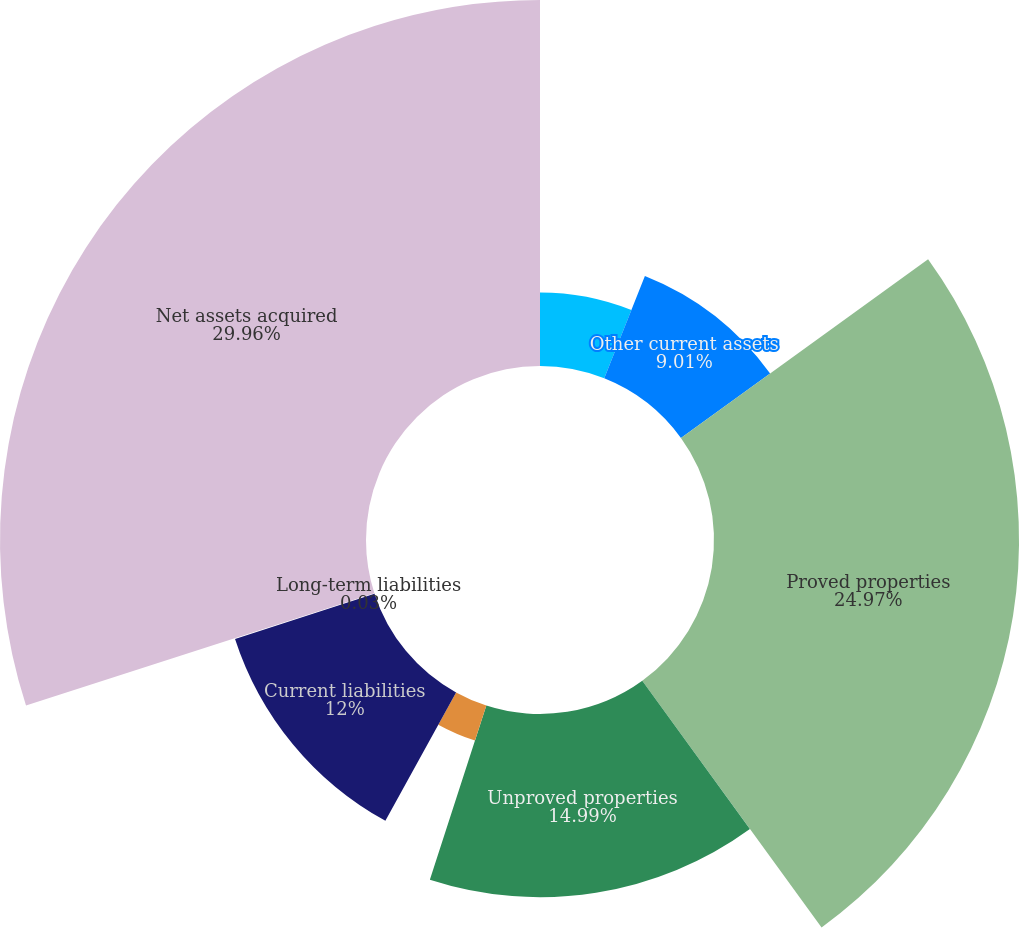<chart> <loc_0><loc_0><loc_500><loc_500><pie_chart><fcel>Cash and cash equivalents<fcel>Other current assets<fcel>Proved properties<fcel>Unproved properties<fcel>Midstream assets<fcel>Current liabilities<fcel>Long-term liabilities<fcel>Net assets acquired<nl><fcel>6.02%<fcel>9.01%<fcel>24.97%<fcel>14.99%<fcel>3.02%<fcel>12.0%<fcel>0.03%<fcel>29.96%<nl></chart> 